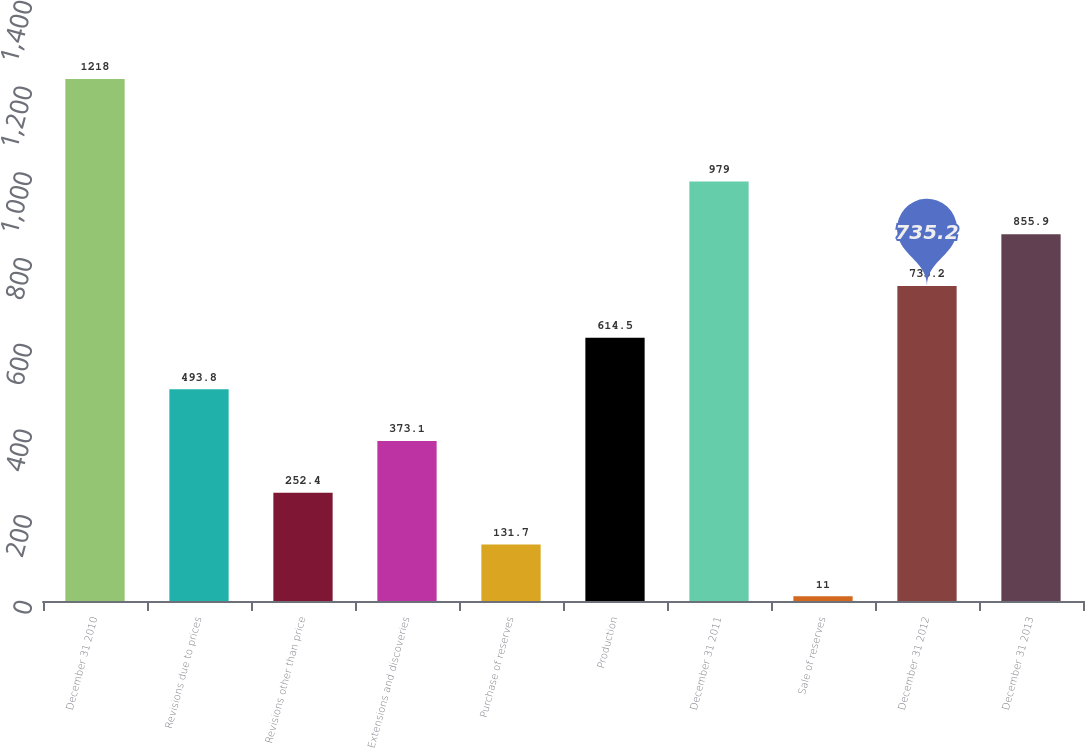Convert chart to OTSL. <chart><loc_0><loc_0><loc_500><loc_500><bar_chart><fcel>December 31 2010<fcel>Revisions due to prices<fcel>Revisions other than price<fcel>Extensions and discoveries<fcel>Purchase of reserves<fcel>Production<fcel>December 31 2011<fcel>Sale of reserves<fcel>December 31 2012<fcel>December 31 2013<nl><fcel>1218<fcel>493.8<fcel>252.4<fcel>373.1<fcel>131.7<fcel>614.5<fcel>979<fcel>11<fcel>735.2<fcel>855.9<nl></chart> 